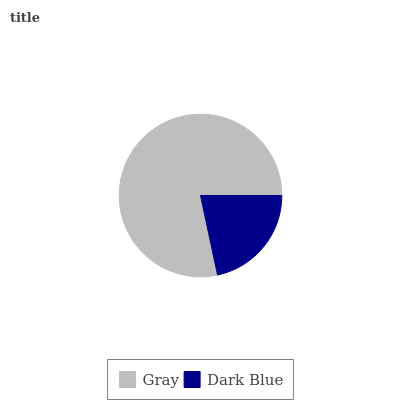Is Dark Blue the minimum?
Answer yes or no. Yes. Is Gray the maximum?
Answer yes or no. Yes. Is Dark Blue the maximum?
Answer yes or no. No. Is Gray greater than Dark Blue?
Answer yes or no. Yes. Is Dark Blue less than Gray?
Answer yes or no. Yes. Is Dark Blue greater than Gray?
Answer yes or no. No. Is Gray less than Dark Blue?
Answer yes or no. No. Is Gray the high median?
Answer yes or no. Yes. Is Dark Blue the low median?
Answer yes or no. Yes. Is Dark Blue the high median?
Answer yes or no. No. Is Gray the low median?
Answer yes or no. No. 